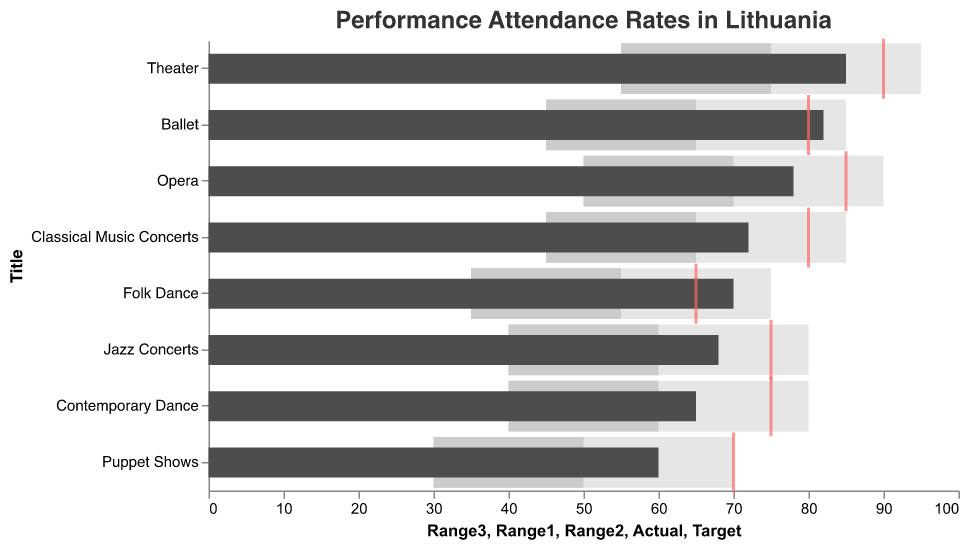What is the actual attendance rate for the Theater shows? The Theater shows have an actual attendance rate represented by the darkest bar. The figure shows that this value aligns with the 'Actual' column data for Theater, which is 85.
Answer: 85 Which type of show met its target attendance rate? To check which show met its target attendance rate, compare the actual attendance rate (dark grey bar) with the target rate (red tick mark). The Ballet's actual rate of 82 exceeds its target of 80.
Answer: Ballet What is the biggest difference between actual and target attendance rates? Calculate the differences between the actual and target rates for each show. The biggest difference is observed for Opera: target (85) minus actual (78) equals 7.
Answer: Opera How many types of shows have an actual attendance rate below 70? Count the types of shows where the actual attendance rate (dark grey bar) is below 70. The shows are Contemporary Dance, Puppet Shows, and Jazz Concerts.
Answer: 3 Which performance type has the smallest range between the highest and lowest ranges (Range3 - Range1)? Calculate the difference between Range3 and Range1 values for each show. The smallest range is observed for Theater: 95 - 55 equals 40.
Answer: Theater Are there any shows where the actual attendance is below the lowest range (Range1)? Compare the actual attendance rates (dark grey bars) to the Range1 values for each show. Puppet Shows is the only show where the actual rate (60) is greater than the lowest range (30).
Answer: No Which show has the highest actual attendance rate? Compare the actual attendance rates (dark grey bars) for all shows. The Theater has the highest actual attendance rate of 85.
Answer: Theater Which shows have exceeded their target attendance rates? Identify shows where actual attendance rates are greater than their target rates. The Ballet and Folk Dance exceed their target rates.
Answer: Ballet, Folk Dance What is the average actual attendance rate across all show types? Sum the actual attendance rates: (78+82+65+70+85+60+72+68) = 580, then divide by the number of shows (8).
Answer: 72.5 For which show type(s) does the actual attendance fall in the "satisfactory" range (Range2)? Inspect each show’s actual attendance rate and compare it with their Range2 values. The shows are Ballet and Folk Dance.
Answer: Ballet, Folk Dance 